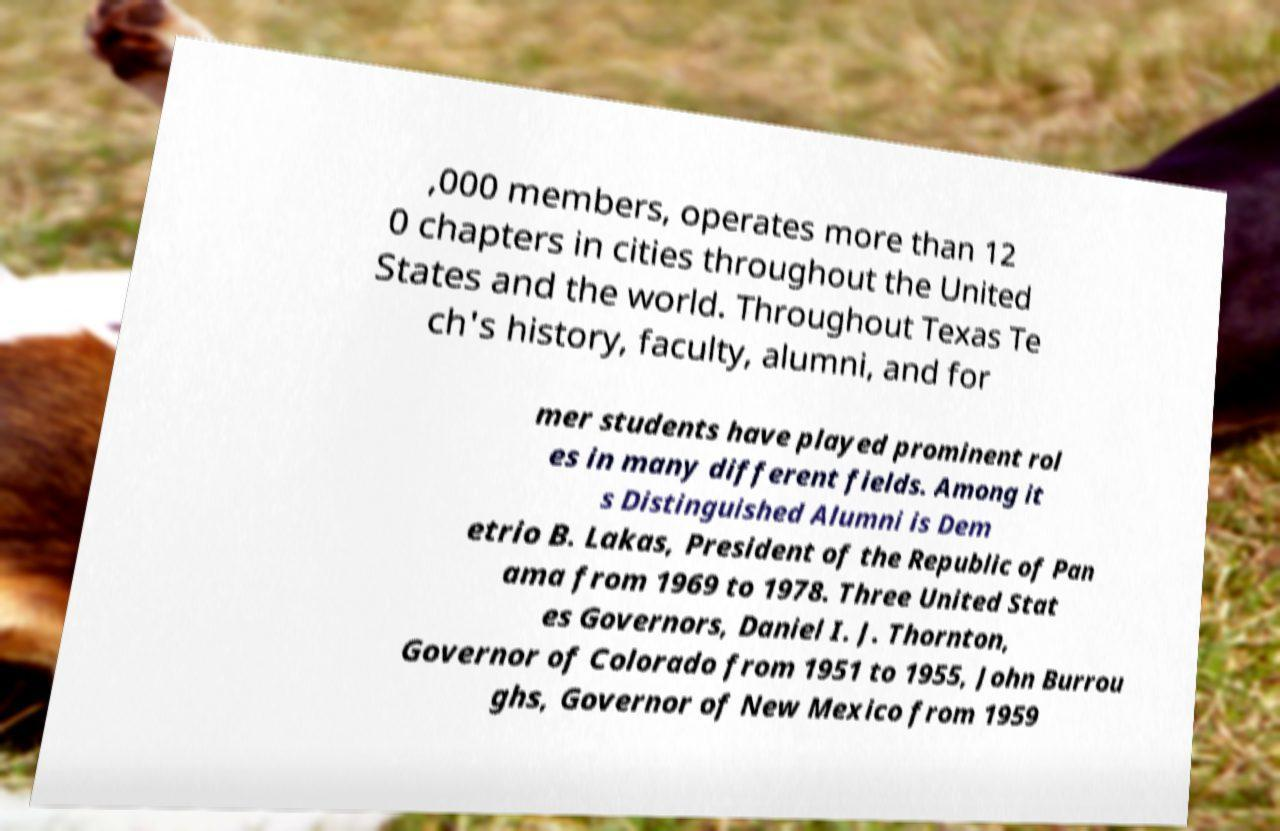Could you assist in decoding the text presented in this image and type it out clearly? ,000 members, operates more than 12 0 chapters in cities throughout the United States and the world. Throughout Texas Te ch's history, faculty, alumni, and for mer students have played prominent rol es in many different fields. Among it s Distinguished Alumni is Dem etrio B. Lakas, President of the Republic of Pan ama from 1969 to 1978. Three United Stat es Governors, Daniel I. J. Thornton, Governor of Colorado from 1951 to 1955, John Burrou ghs, Governor of New Mexico from 1959 